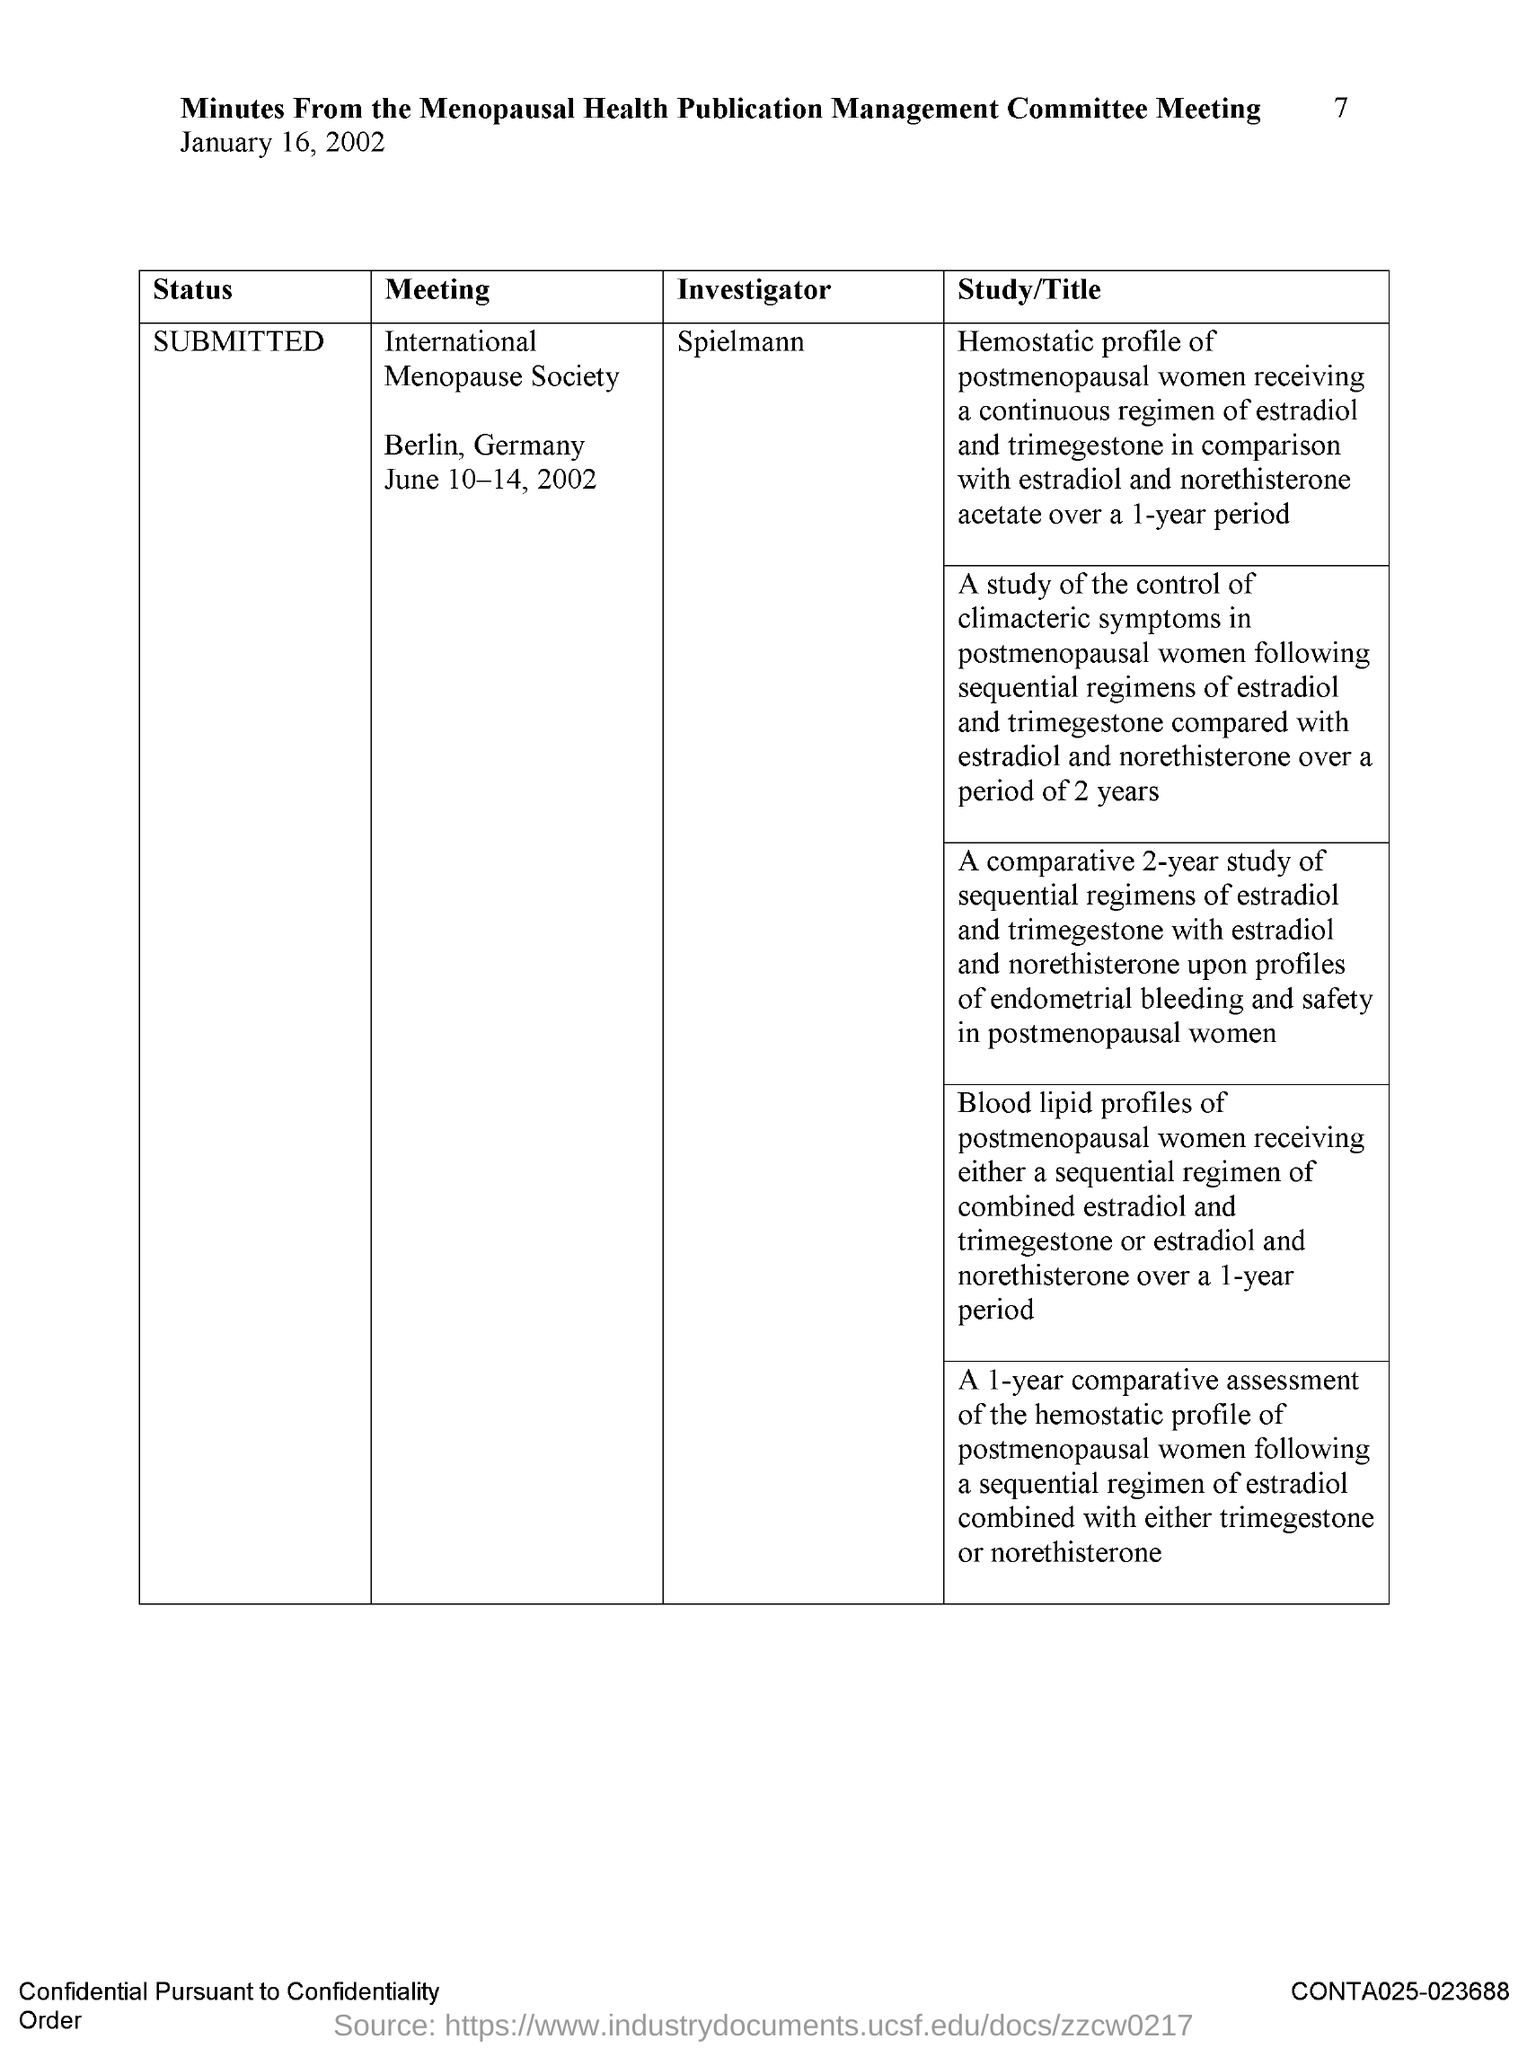Point out several critical features in this image. The meeting is about the International Menopause Society. Spielmann is the investigator. The meeting will be held on June 10-14, 2002. The meeting will take place in Berlin, Germany. The document is dated January 16, 2002. 